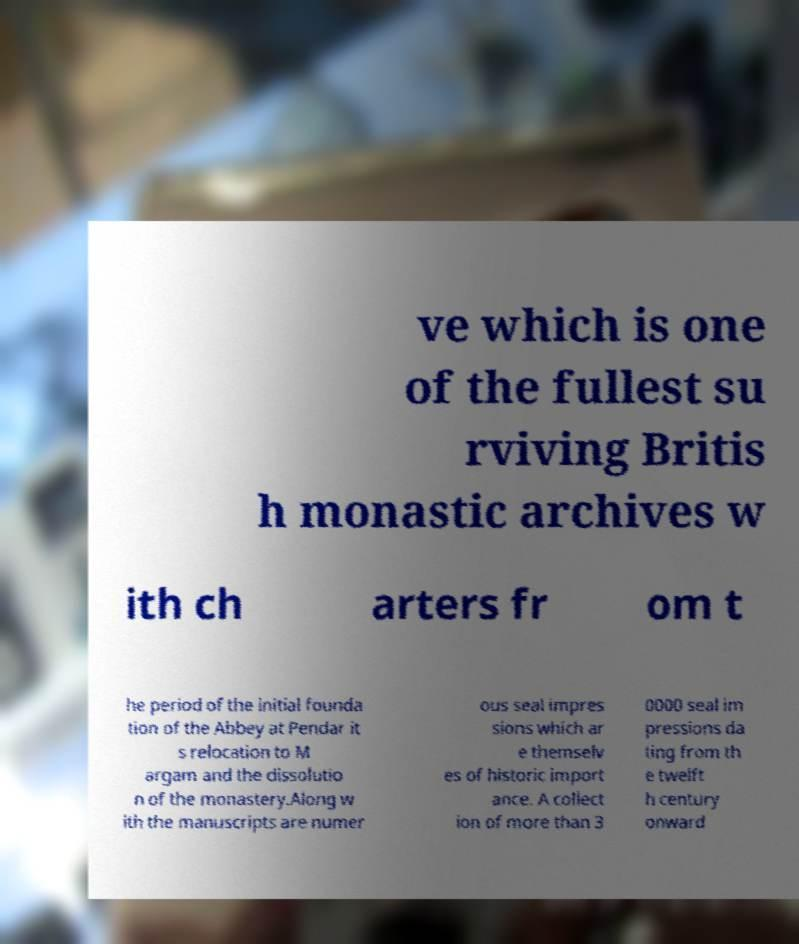What messages or text are displayed in this image? I need them in a readable, typed format. ve which is one of the fullest su rviving Britis h monastic archives w ith ch arters fr om t he period of the initial founda tion of the Abbey at Pendar it s relocation to M argam and the dissolutio n of the monastery.Along w ith the manuscripts are numer ous seal impres sions which ar e themselv es of historic import ance. A collect ion of more than 3 0000 seal im pressions da ting from th e twelft h century onward 